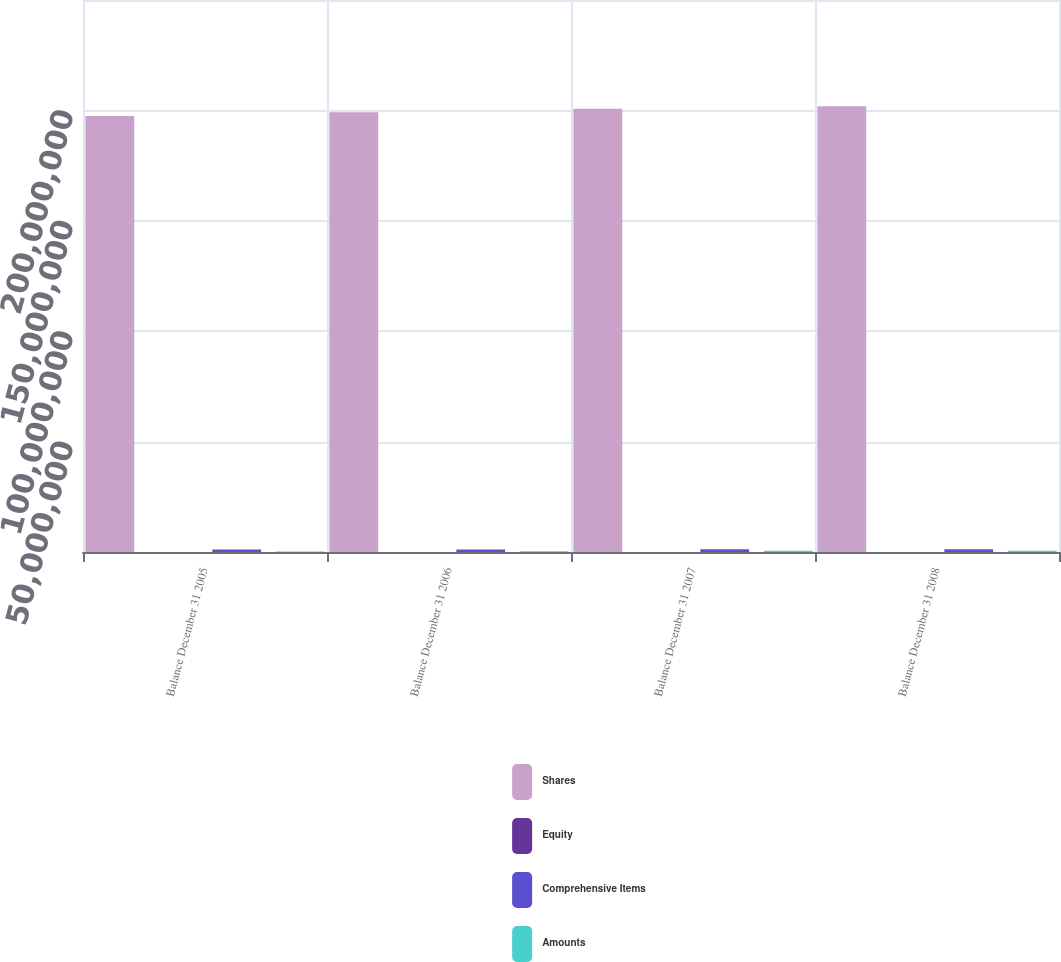<chart> <loc_0><loc_0><loc_500><loc_500><stacked_bar_chart><ecel><fcel>Balance December 31 2005<fcel>Balance December 31 2006<fcel>Balance December 31 2007<fcel>Balance December 31 2008<nl><fcel>Shares<fcel>1.97494e+08<fcel>1.9911e+08<fcel>2.00693e+08<fcel>2.01931e+08<nl><fcel>Equity<fcel>1975<fcel>1991<fcel>2007<fcel>2019<nl><fcel>Comprehensive Items<fcel>1.10495e+06<fcel>1.1441e+06<fcel>1.20951e+06<fcel>1.25006e+06<nl><fcel>Amounts<fcel>244524<fcel>373387<fcel>509875<fcel>591912<nl></chart> 